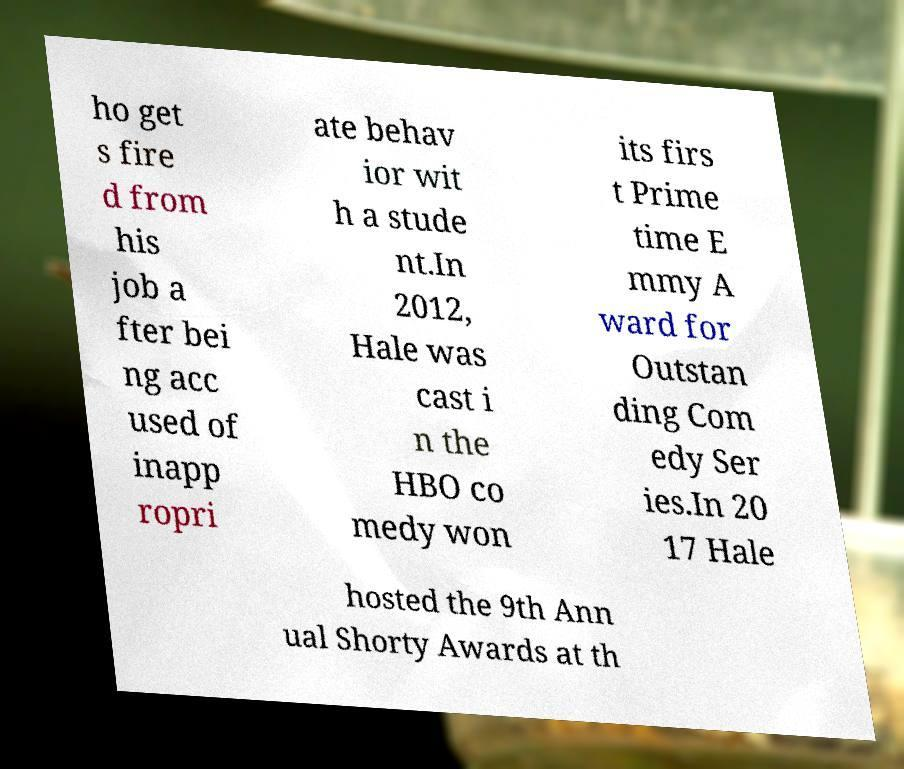Could you assist in decoding the text presented in this image and type it out clearly? ho get s fire d from his job a fter bei ng acc used of inapp ropri ate behav ior wit h a stude nt.In 2012, Hale was cast i n the HBO co medy won its firs t Prime time E mmy A ward for Outstan ding Com edy Ser ies.In 20 17 Hale hosted the 9th Ann ual Shorty Awards at th 